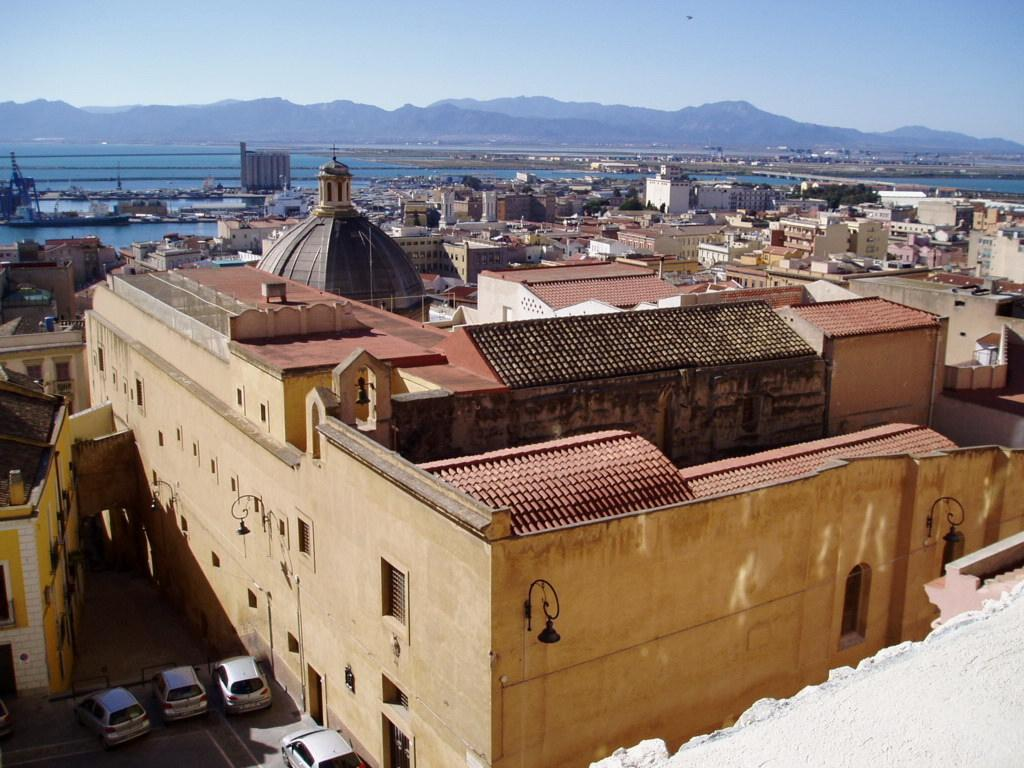What type of structures can be seen in the image? There are buildings in the image. What type of vehicles are present in the image? There are cars in the image. What natural feature is visible in the image? There is water visible in the image. What type of terrain can be seen in the image? There are hills in the image. What is the color of the sky in the image? The sky is blue in the image. How many women are walking on the ice in the image? There is no ice or women present in the image. What type of advice does the father give in the image? There is no father or advice-giving scene present in the image. 